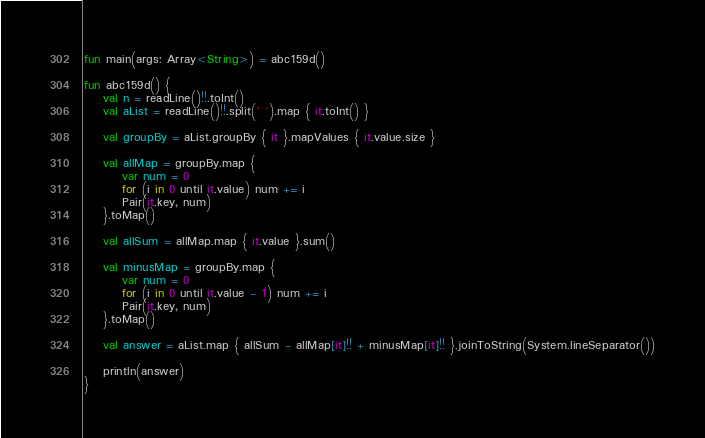Convert code to text. <code><loc_0><loc_0><loc_500><loc_500><_Kotlin_>fun main(args: Array<String>) = abc159d()

fun abc159d() {
    val n = readLine()!!.toInt()
    val aList = readLine()!!.split(' ').map { it.toInt() }

    val groupBy = aList.groupBy { it }.mapValues { it.value.size }

    val allMap = groupBy.map {
        var num = 0
        for (i in 0 until it.value) num += i
        Pair(it.key, num)
    }.toMap()

    val allSum = allMap.map { it.value }.sum()

    val minusMap = groupBy.map {
        var num = 0
        for (i in 0 until it.value - 1) num += i
        Pair(it.key, num)
    }.toMap()

    val answer = aList.map { allSum - allMap[it]!! + minusMap[it]!! }.joinToString(System.lineSeparator())

    println(answer)
}
</code> 